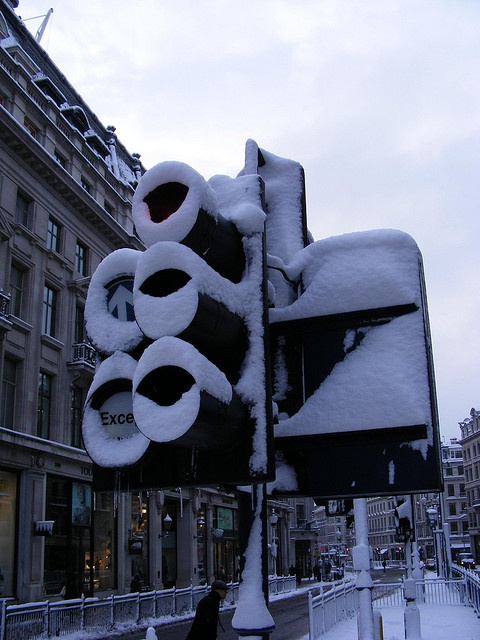Describe the objects in this image and their specific colors. I can see traffic light in black and gray tones, traffic light in black and gray tones, people in black, navy, purple, and darkblue tones, people in black tones, and people in black, navy, purple, and darkblue tones in this image. 